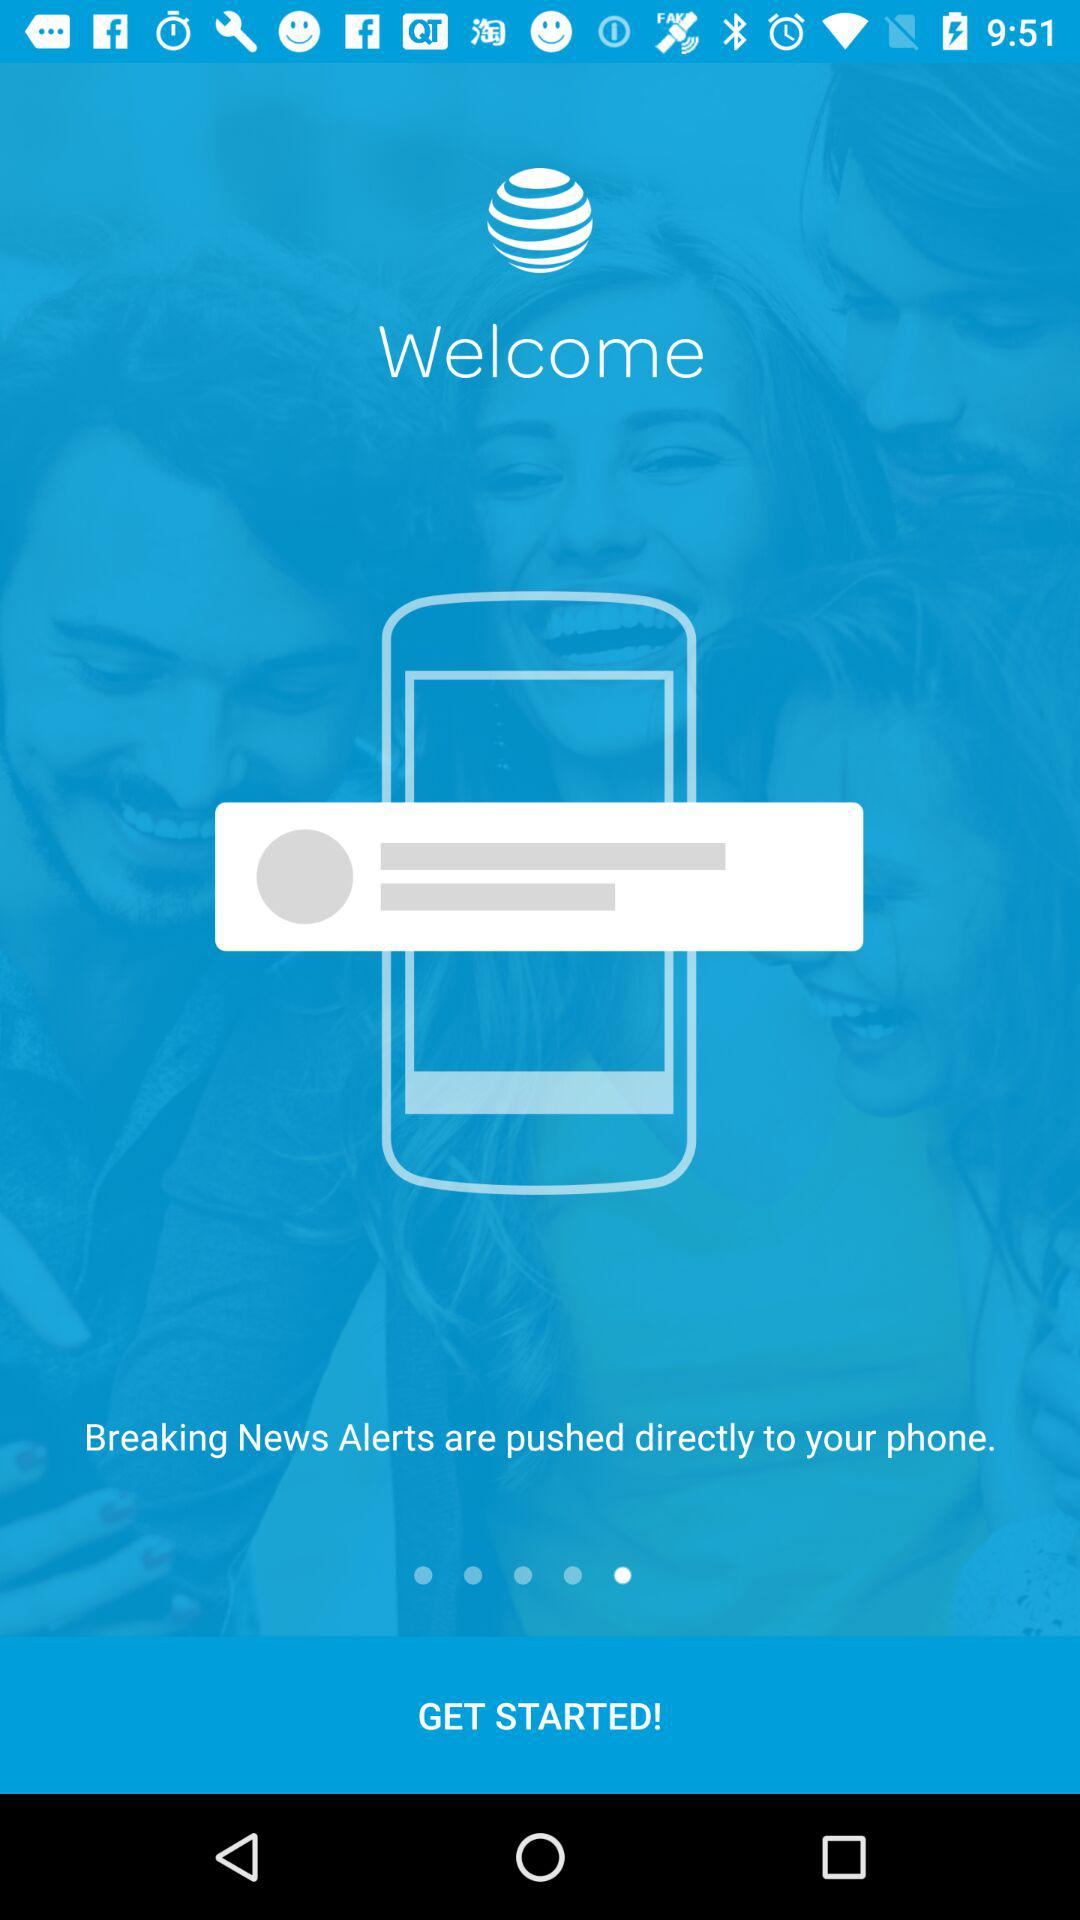Where are breaking news alerts pushed? Breaking news alerts are pushed directly to your phone. 